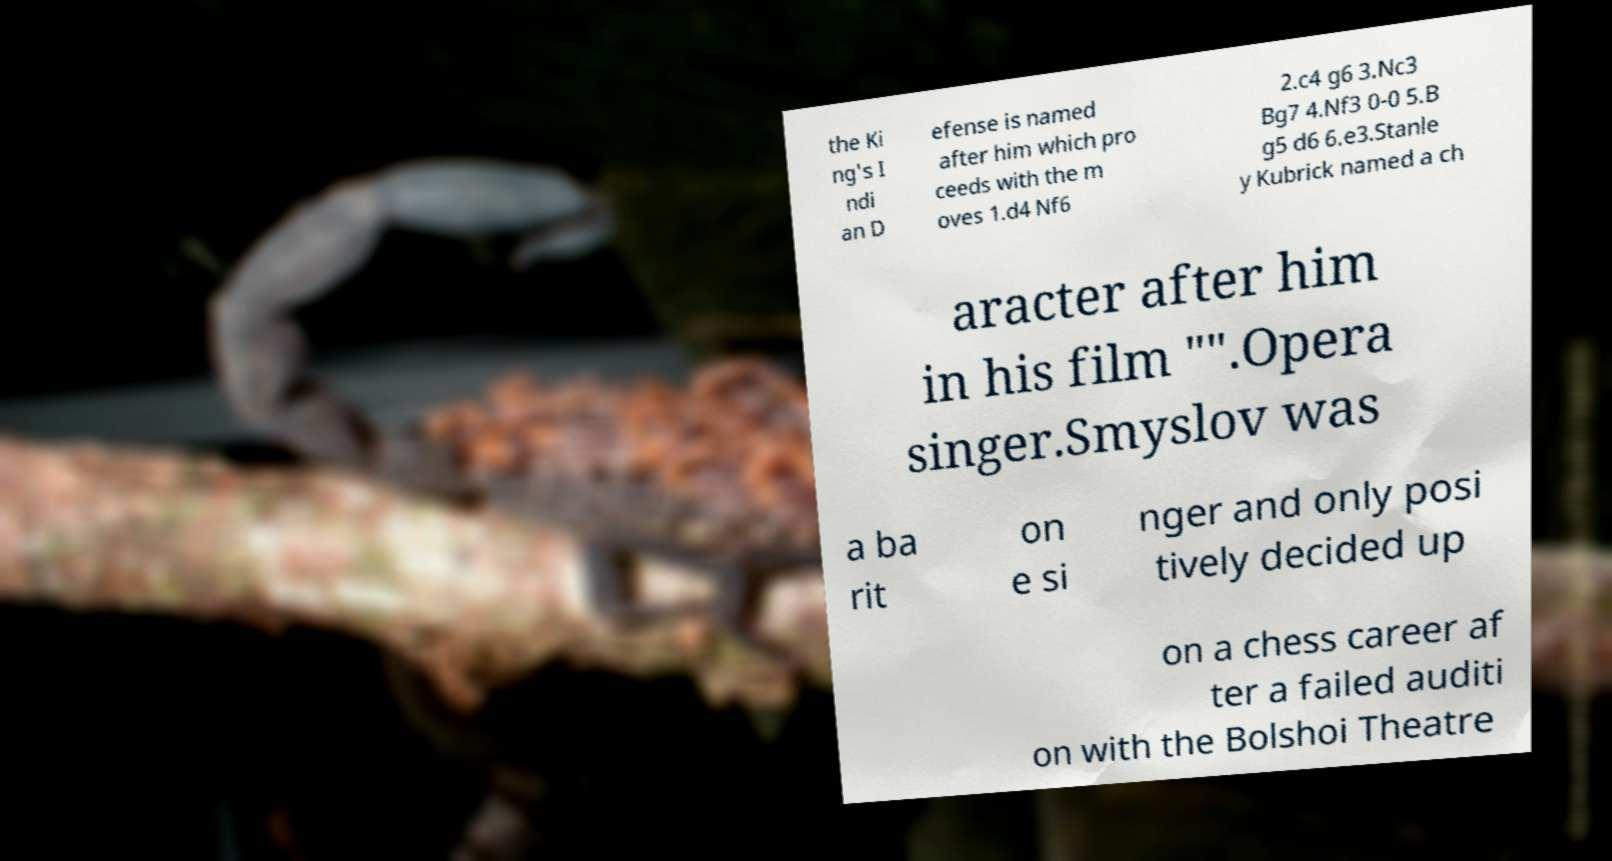What messages or text are displayed in this image? I need them in a readable, typed format. the Ki ng's I ndi an D efense is named after him which pro ceeds with the m oves 1.d4 Nf6 2.c4 g6 3.Nc3 Bg7 4.Nf3 0-0 5.B g5 d6 6.e3.Stanle y Kubrick named a ch aracter after him in his film "".Opera singer.Smyslov was a ba rit on e si nger and only posi tively decided up on a chess career af ter a failed auditi on with the Bolshoi Theatre 